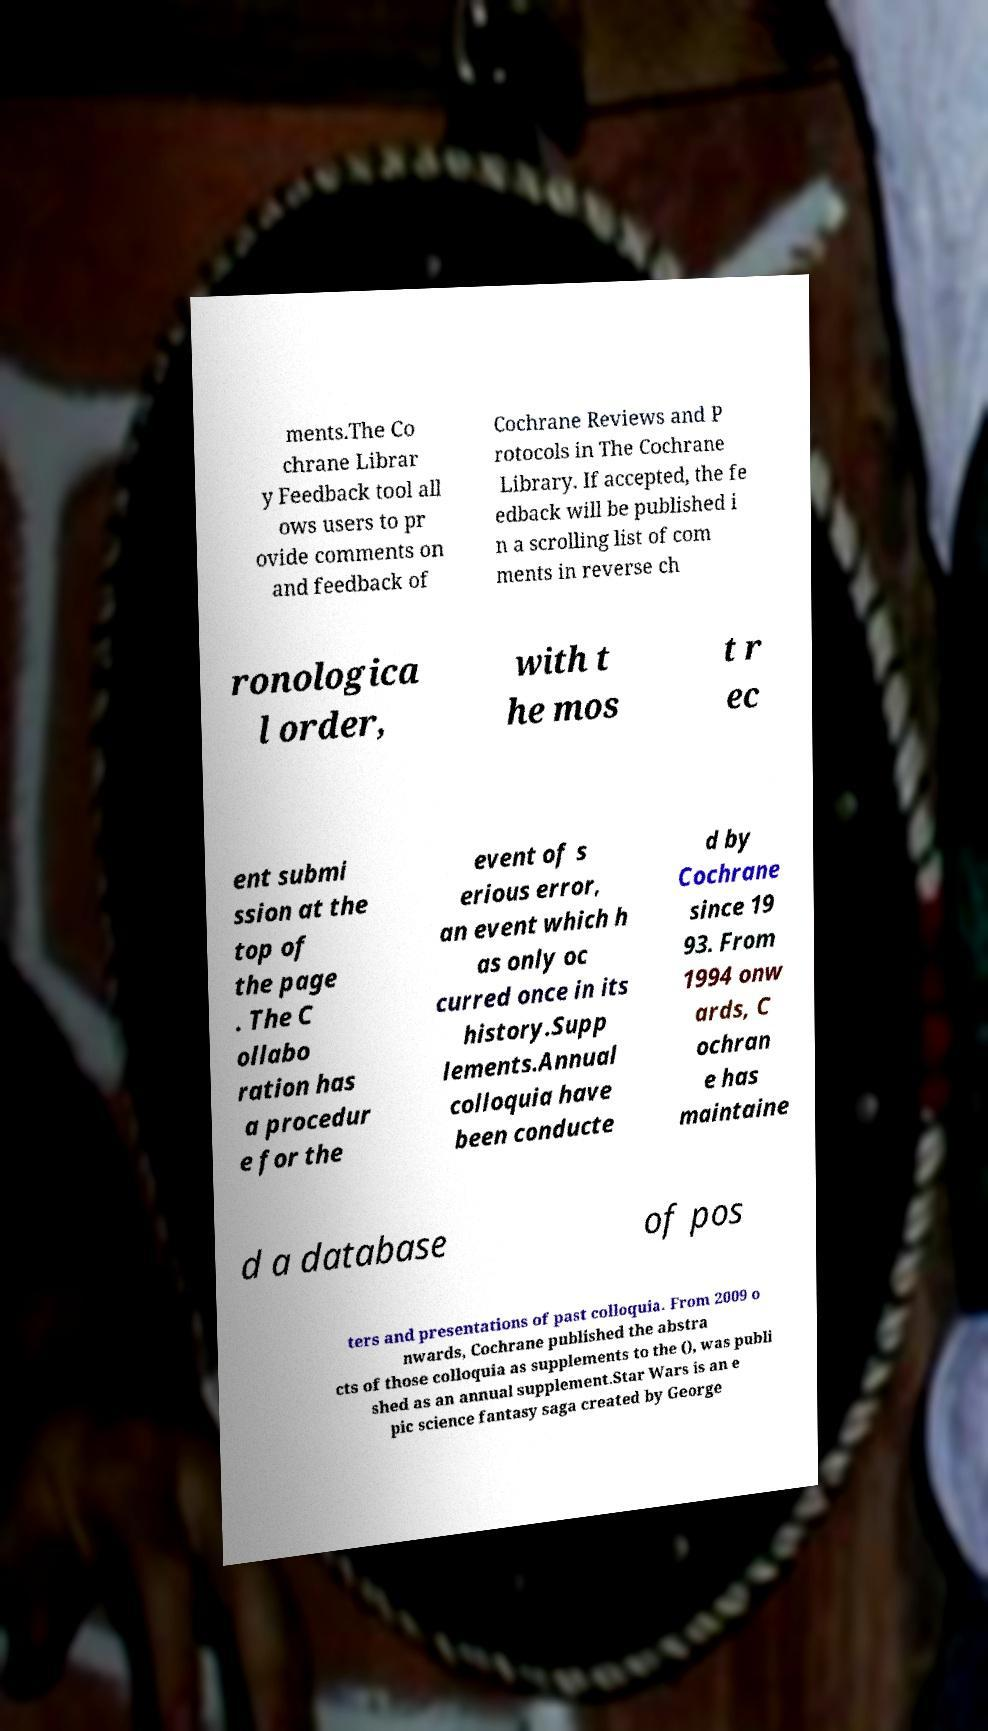Please identify and transcribe the text found in this image. ments.The Co chrane Librar y Feedback tool all ows users to pr ovide comments on and feedback of Cochrane Reviews and P rotocols in The Cochrane Library. If accepted, the fe edback will be published i n a scrolling list of com ments in reverse ch ronologica l order, with t he mos t r ec ent submi ssion at the top of the page . The C ollabo ration has a procedur e for the event of s erious error, an event which h as only oc curred once in its history.Supp lements.Annual colloquia have been conducte d by Cochrane since 19 93. From 1994 onw ards, C ochran e has maintaine d a database of pos ters and presentations of past colloquia. From 2009 o nwards, Cochrane published the abstra cts of those colloquia as supplements to the (), was publi shed as an annual supplement.Star Wars is an e pic science fantasy saga created by George 